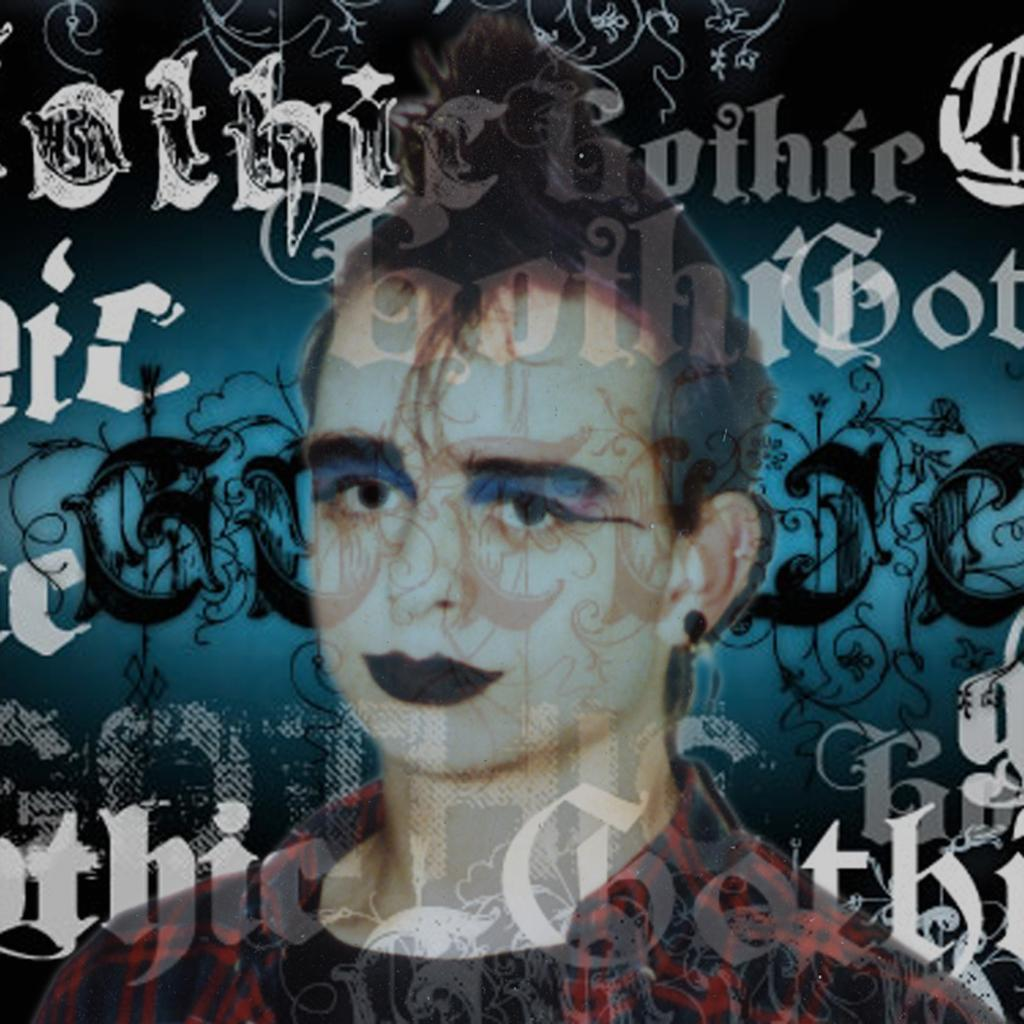What is the main subject of the picture? The main subject of the picture is a person. Can you describe the appearance of the person in the image? The person in the image is wearing black lipstick and has a funky hairstyle. Where is the image placed? The image is placed on a painting words board. How many cubs are playing with the person in the image? There are no cubs present in the image. Are the person's sisters in the image? The provided facts do not mention any sisters, so it cannot be determined from the image. 